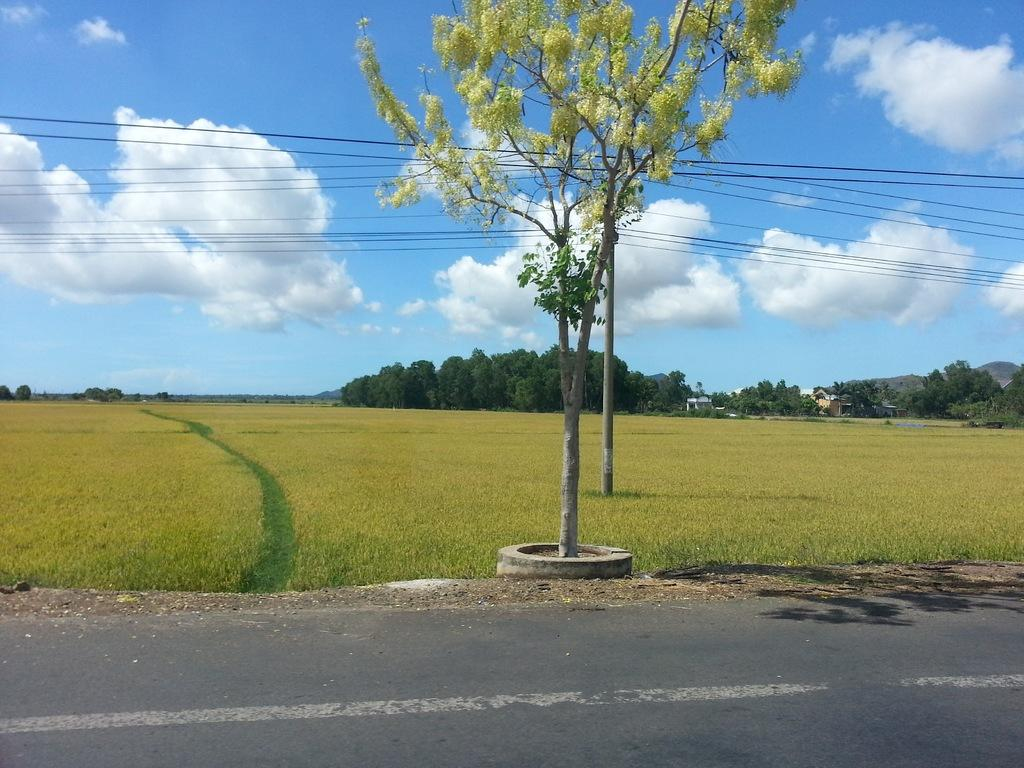What is located at the front of the image? There is a road in the front of the image. What type of landscape is visible behind the road? There is grassland behind the road. What can be seen in the background of the image? Trees are present in the background of the image. What is visible in the sky in the image? The sky is visible in the image, and clouds are present in the sky. What statement does the mom make about the value of the grassland in the image? There is no mom or statement about the value of the grassland present in the image. 